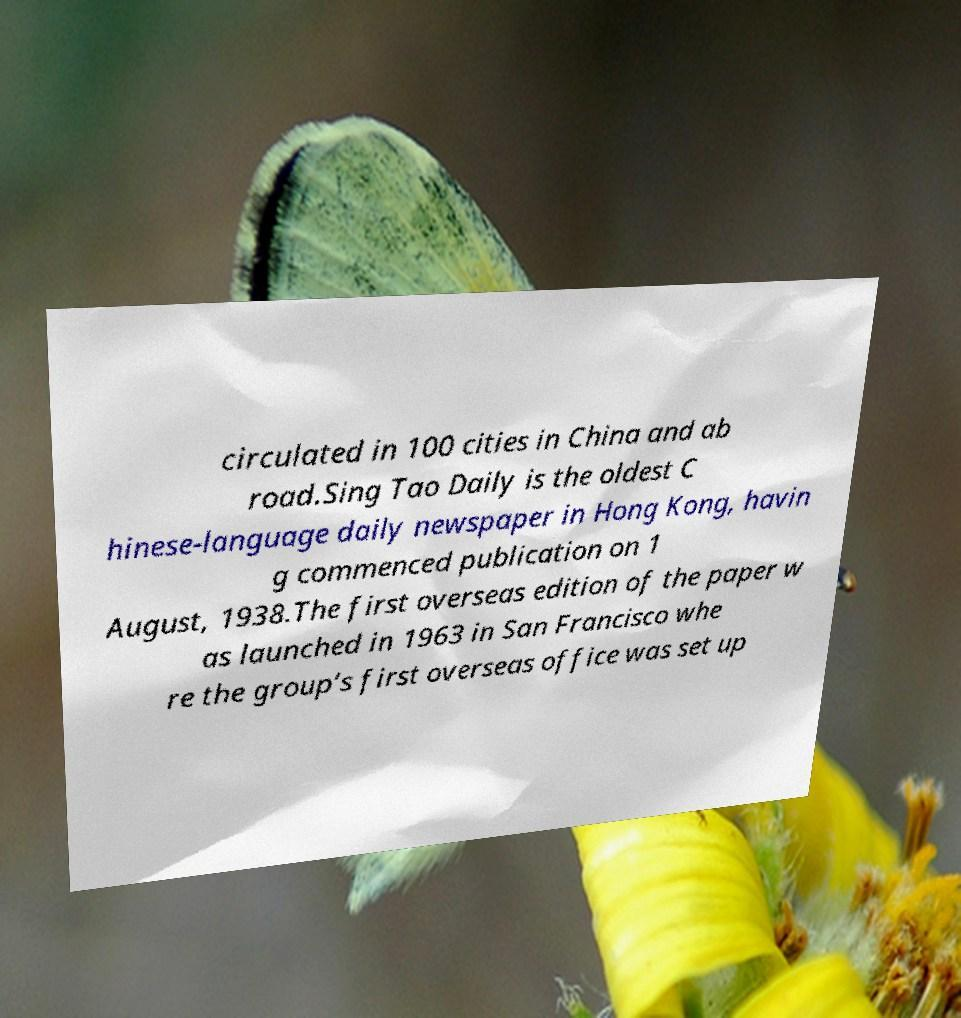Could you assist in decoding the text presented in this image and type it out clearly? circulated in 100 cities in China and ab road.Sing Tao Daily is the oldest C hinese-language daily newspaper in Hong Kong, havin g commenced publication on 1 August, 1938.The first overseas edition of the paper w as launched in 1963 in San Francisco whe re the group’s first overseas office was set up 